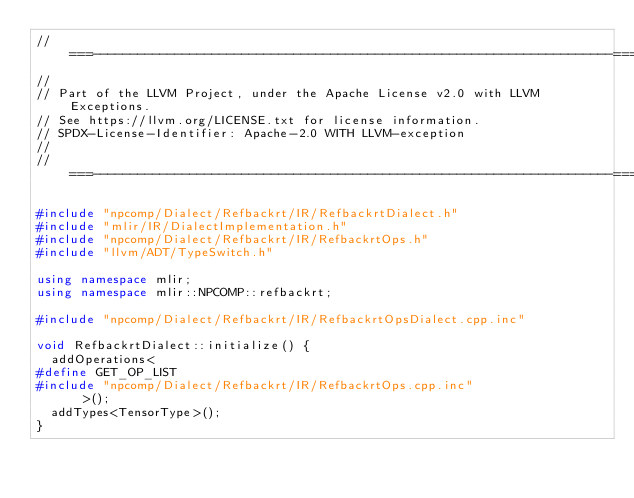<code> <loc_0><loc_0><loc_500><loc_500><_C++_>//===----------------------------------------------------------------------===//
//
// Part of the LLVM Project, under the Apache License v2.0 with LLVM Exceptions.
// See https://llvm.org/LICENSE.txt for license information.
// SPDX-License-Identifier: Apache-2.0 WITH LLVM-exception
//
//===----------------------------------------------------------------------===//

#include "npcomp/Dialect/Refbackrt/IR/RefbackrtDialect.h"
#include "mlir/IR/DialectImplementation.h"
#include "npcomp/Dialect/Refbackrt/IR/RefbackrtOps.h"
#include "llvm/ADT/TypeSwitch.h"

using namespace mlir;
using namespace mlir::NPCOMP::refbackrt;

#include "npcomp/Dialect/Refbackrt/IR/RefbackrtOpsDialect.cpp.inc"

void RefbackrtDialect::initialize() {
  addOperations<
#define GET_OP_LIST
#include "npcomp/Dialect/Refbackrt/IR/RefbackrtOps.cpp.inc"
      >();
  addTypes<TensorType>();
}
</code> 